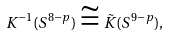<formula> <loc_0><loc_0><loc_500><loc_500>K ^ { - 1 } ( S ^ { 8 - p } ) \cong \tilde { K } ( S ^ { 9 - p } ) ,</formula> 